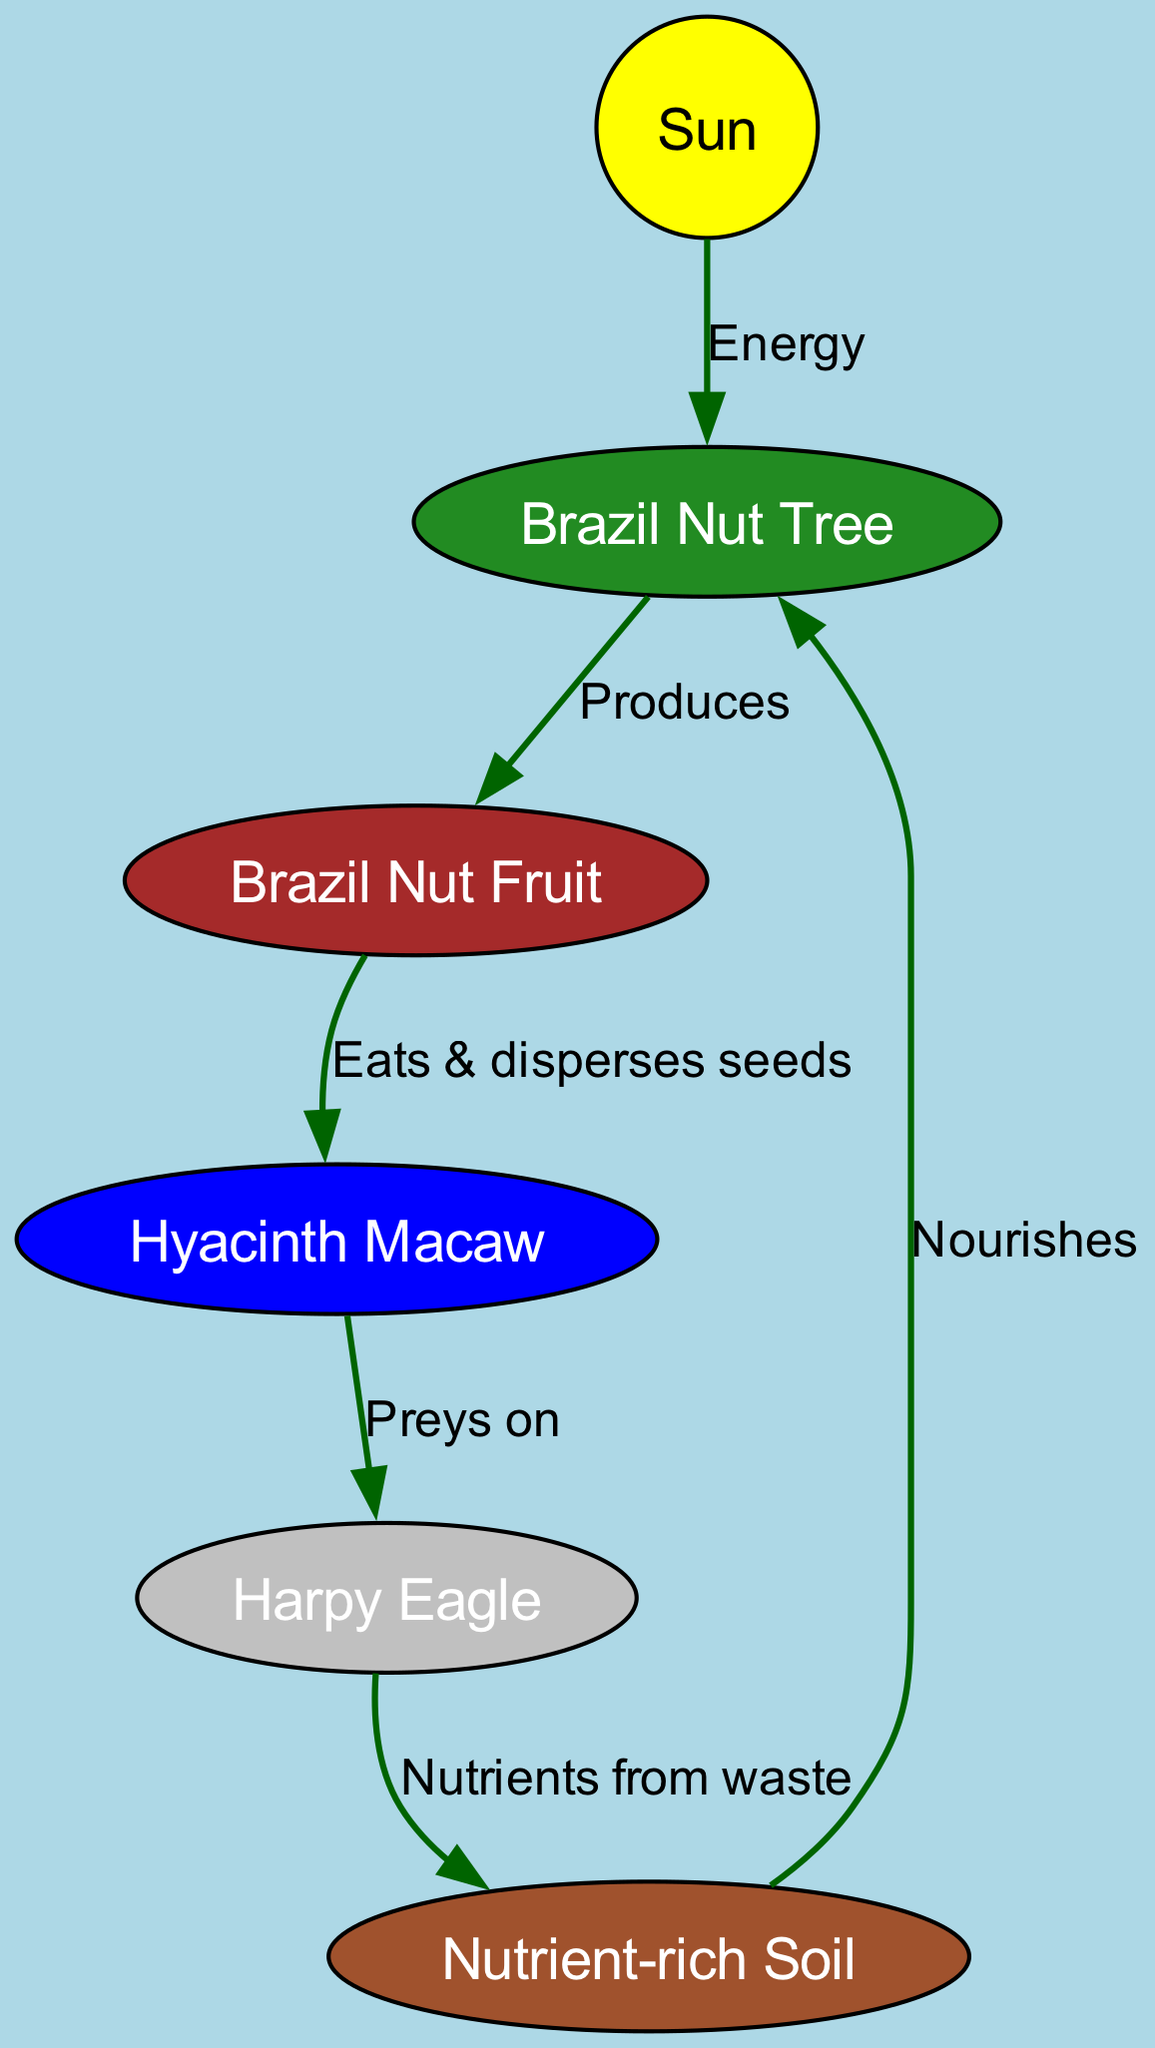What is the primary energy source for the Brazil Nut Tree? The diagram shows that the Sun is connected to the Brazil Nut Tree with a directed edge labeled "Energy." This indicates that the Sun provides energy for the tree to grow.
Answer: Sun How many nodes are present in the diagram? By counting the nodes listed in the data, we find that there are six nodes: Sun, Brazil Nut Tree, Brazil Nut Fruit, Hyacinth Macaw, Harpy Eagle, and Nutrient-rich Soil.
Answer: 6 What does the Hyacinth Macaw eat? The edge going from the Brazil Nut Fruit to the Hyacinth Macaw is labeled "Eats & disperses seeds," indicating that the Hyacinth Macaw eats Brazil Nut Fruit.
Answer: Brazil Nut Fruit What role does the Harpy Eagle play in this food chain? The Harpy Eagle is connected to the Hyacinth Macaw by a directed edge labeled "Preys on," indicating that the Harpy Eagle hunts the Hyacinth Macaw.
Answer: Preys on Hyacinth Macaw How does the nutrient-rich soil benefit the Brazil Nut Tree? The nutrient-rich soil has a directed edge pointing to the Brazil Nut Tree labeled "Nourishes," indicating that it provides nutrients which help the tree to grow.
Answer: Nourishes What happens to the nutrients from the Harpy Eagle? The diagram shows that there is a directed edge from the Harpy Eagle to the nutrient-rich soil labeled "Nutrients from waste," which means that the nutrients from the Harpy Eagle eventually contribute to the soil.
Answer: Nutrients from waste What is produced by the Brazil Nut Tree? According to the diagram, there is an edge from the Brazil Nut Tree to the Brazil Nut Fruit labeled "Produces," which defines the output of the tree.
Answer: Brazil Nut Fruit Why is the Hyacinth Macaw important for forest regeneration? The diagram shows that the Hyacinth Macaw eats Brazil Nut Fruit and disperses the seeds, which is critical for the growth of new Brazil Nut Trees and hence for forest regeneration.
Answer: Disperses seeds 